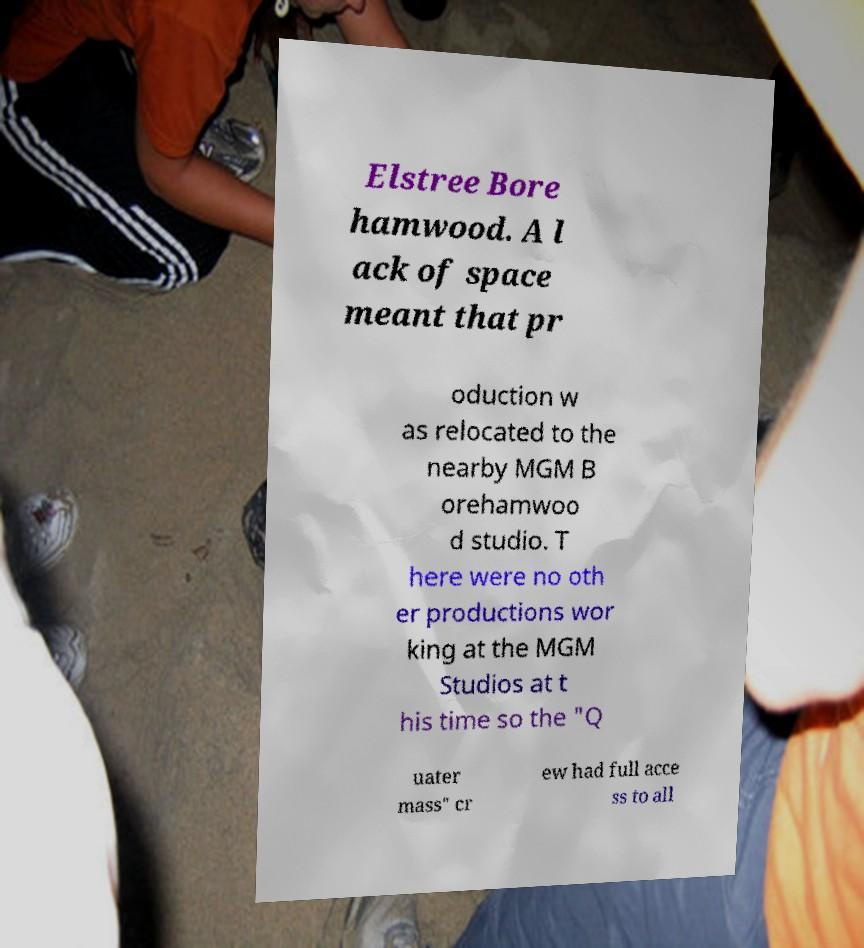Please read and relay the text visible in this image. What does it say? Elstree Bore hamwood. A l ack of space meant that pr oduction w as relocated to the nearby MGM B orehamwoo d studio. T here were no oth er productions wor king at the MGM Studios at t his time so the "Q uater mass" cr ew had full acce ss to all 